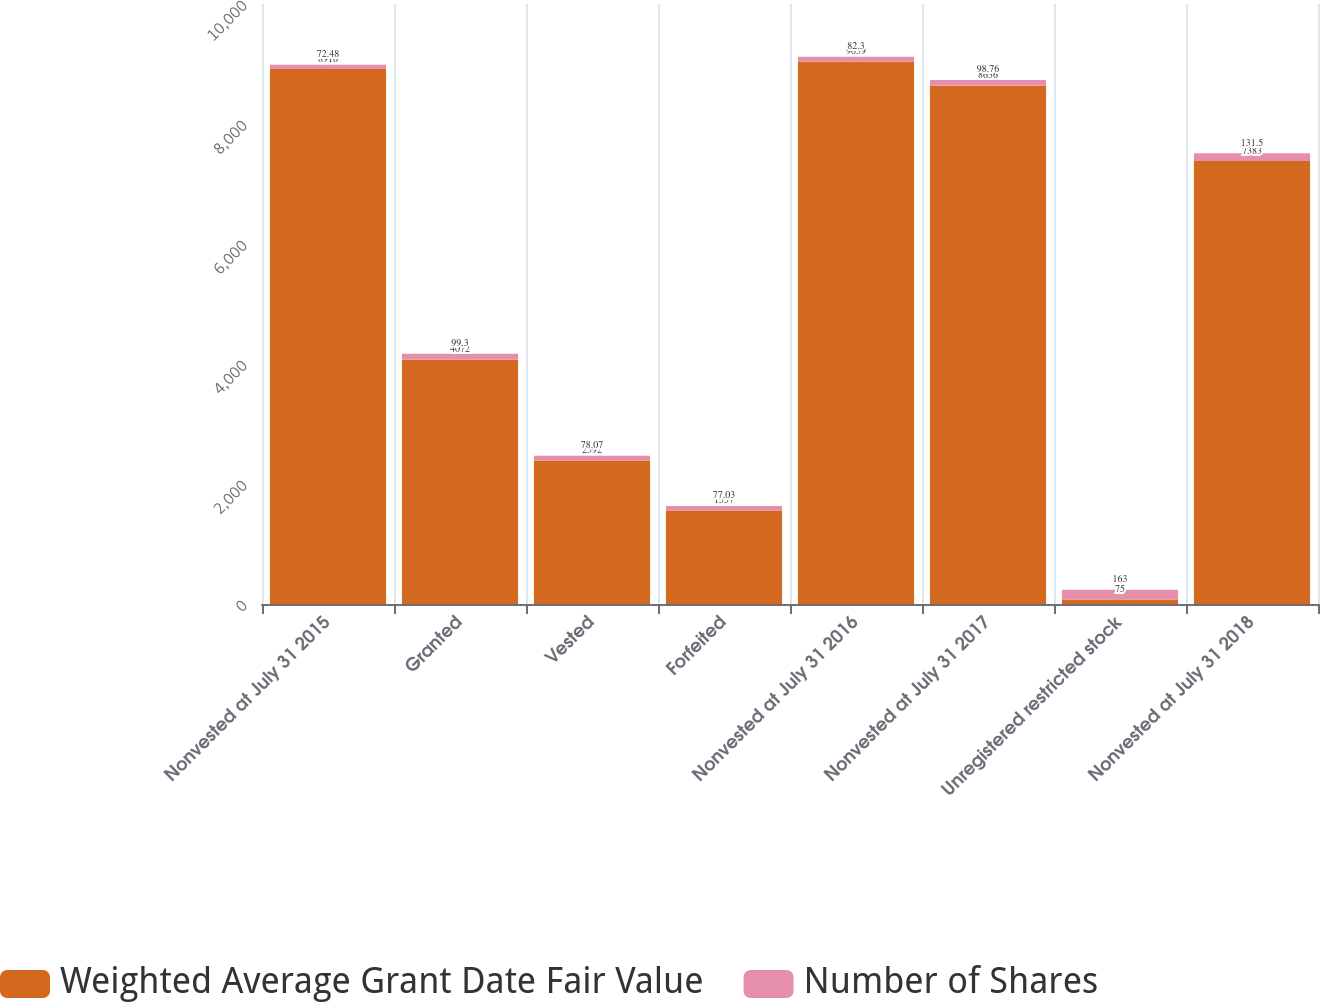<chart> <loc_0><loc_0><loc_500><loc_500><stacked_bar_chart><ecel><fcel>Nonvested at July 31 2015<fcel>Granted<fcel>Vested<fcel>Forfeited<fcel>Nonvested at July 31 2016<fcel>Nonvested at July 31 2017<fcel>Unregistered restricted stock<fcel>Nonvested at July 31 2018<nl><fcel>Weighted Average Grant Date Fair Value<fcel>8916<fcel>4072<fcel>2392<fcel>1557<fcel>9039<fcel>8636<fcel>75<fcel>7383<nl><fcel>Number of Shares<fcel>72.48<fcel>99.3<fcel>78.07<fcel>77.03<fcel>82.3<fcel>98.76<fcel>163<fcel>131.5<nl></chart> 